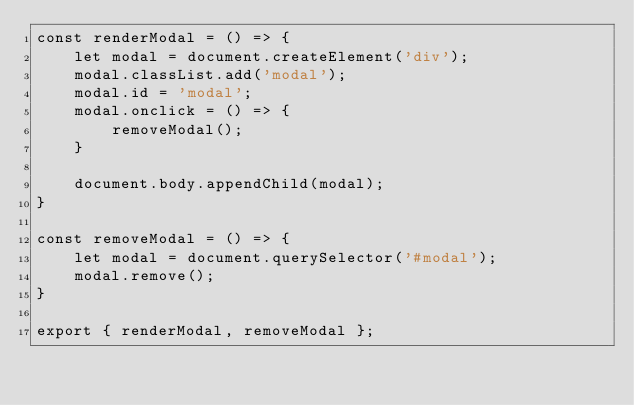Convert code to text. <code><loc_0><loc_0><loc_500><loc_500><_JavaScript_>const renderModal = () => {
    let modal = document.createElement('div');
    modal.classList.add('modal');
    modal.id = 'modal';
    modal.onclick = () => {
        removeModal();
    }

    document.body.appendChild(modal);
}

const removeModal = () => {
    let modal = document.querySelector('#modal');
    modal.remove();
}

export { renderModal, removeModal };</code> 